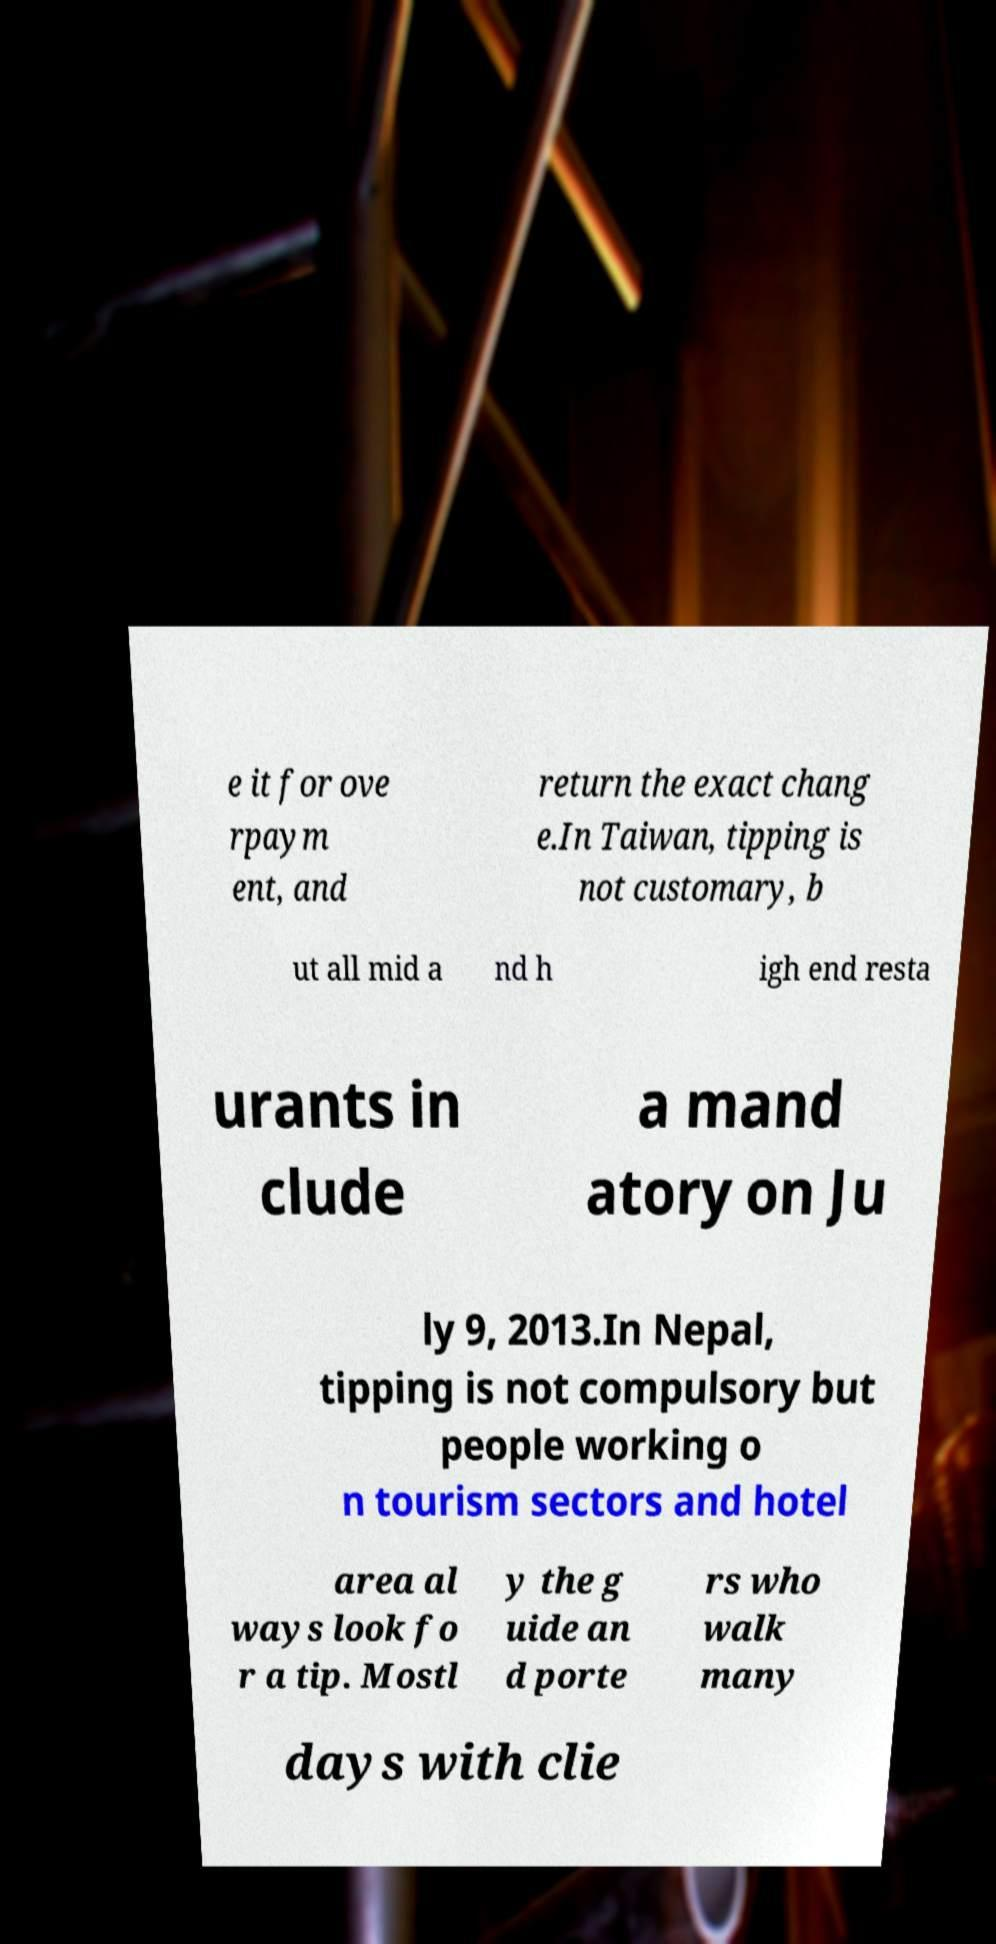Could you assist in decoding the text presented in this image and type it out clearly? e it for ove rpaym ent, and return the exact chang e.In Taiwan, tipping is not customary, b ut all mid a nd h igh end resta urants in clude a mand atory on Ju ly 9, 2013.In Nepal, tipping is not compulsory but people working o n tourism sectors and hotel area al ways look fo r a tip. Mostl y the g uide an d porte rs who walk many days with clie 